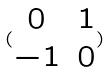Convert formula to latex. <formula><loc_0><loc_0><loc_500><loc_500>( \begin{matrix} 0 & 1 \\ - 1 & 0 \end{matrix} )</formula> 